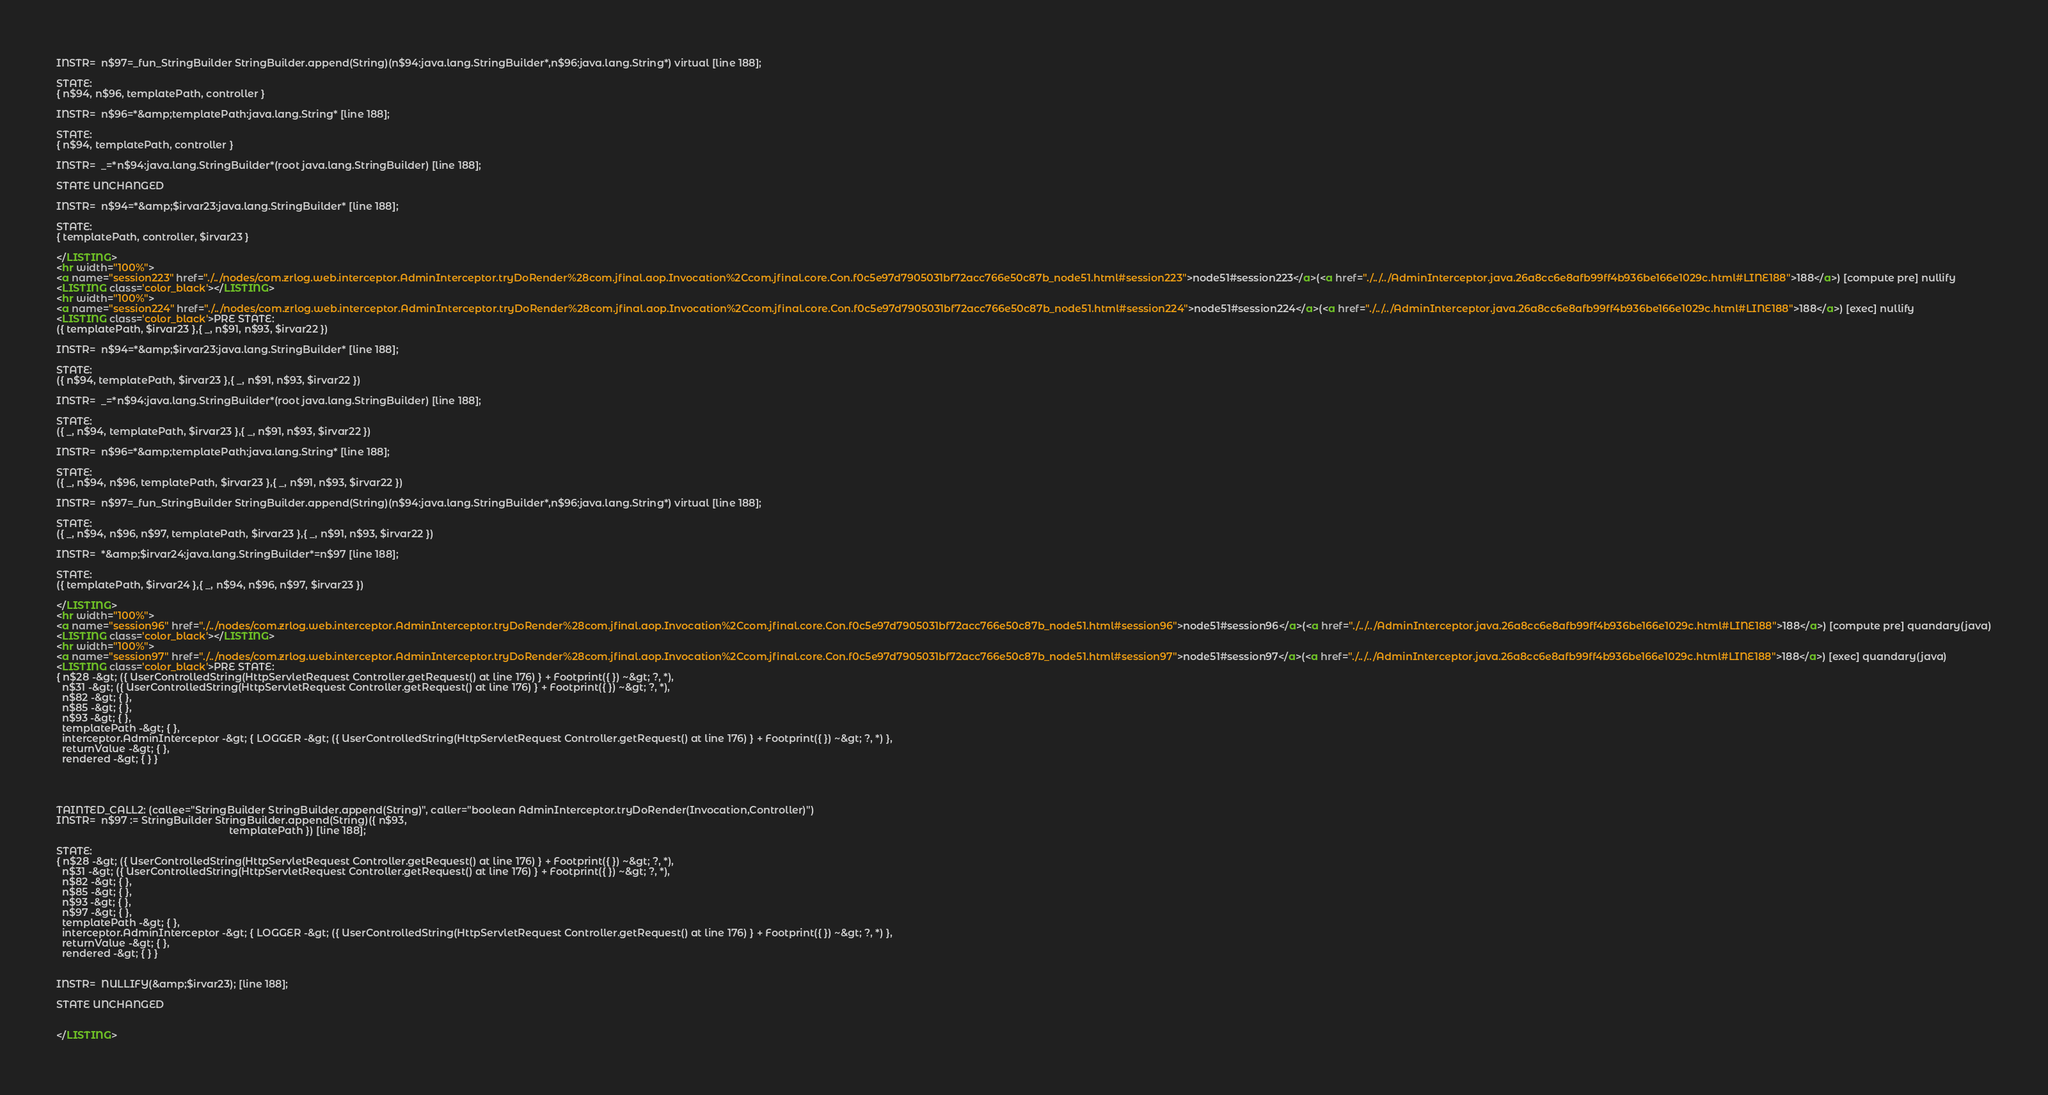Convert code to text. <code><loc_0><loc_0><loc_500><loc_500><_HTML_>INSTR=  n$97=_fun_StringBuilder StringBuilder.append(String)(n$94:java.lang.StringBuilder*,n$96:java.lang.String*) virtual [line 188]; 

STATE:
{ n$94, n$96, templatePath, controller }

INSTR=  n$96=*&amp;templatePath:java.lang.String* [line 188]; 

STATE:
{ n$94, templatePath, controller }

INSTR=  _=*n$94:java.lang.StringBuilder*(root java.lang.StringBuilder) [line 188]; 

STATE UNCHANGED

INSTR=  n$94=*&amp;$irvar23:java.lang.StringBuilder* [line 188]; 

STATE:
{ templatePath, controller, $irvar23 }

</LISTING>
<hr width="100%">
<a name="session223" href="./../nodes/com.zrlog.web.interceptor.AdminInterceptor.tryDoRender%28com.jfinal.aop.Invocation%2Ccom.jfinal.core.Con.f0c5e97d7905031bf72acc766e50c87b_node51.html#session223">node51#session223</a>(<a href="./../../AdminInterceptor.java.26a8cc6e8afb99ff4b936be166e1029c.html#LINE188">188</a>) [compute pre] nullify
<LISTING class='color_black'></LISTING>
<hr width="100%">
<a name="session224" href="./../nodes/com.zrlog.web.interceptor.AdminInterceptor.tryDoRender%28com.jfinal.aop.Invocation%2Ccom.jfinal.core.Con.f0c5e97d7905031bf72acc766e50c87b_node51.html#session224">node51#session224</a>(<a href="./../../AdminInterceptor.java.26a8cc6e8afb99ff4b936be166e1029c.html#LINE188">188</a>) [exec] nullify
<LISTING class='color_black'>PRE STATE:
({ templatePath, $irvar23 },{ _, n$91, n$93, $irvar22 })

INSTR=  n$94=*&amp;$irvar23:java.lang.StringBuilder* [line 188]; 

STATE:
({ n$94, templatePath, $irvar23 },{ _, n$91, n$93, $irvar22 })

INSTR=  _=*n$94:java.lang.StringBuilder*(root java.lang.StringBuilder) [line 188]; 

STATE:
({ _, n$94, templatePath, $irvar23 },{ _, n$91, n$93, $irvar22 })

INSTR=  n$96=*&amp;templatePath:java.lang.String* [line 188]; 

STATE:
({ _, n$94, n$96, templatePath, $irvar23 },{ _, n$91, n$93, $irvar22 })

INSTR=  n$97=_fun_StringBuilder StringBuilder.append(String)(n$94:java.lang.StringBuilder*,n$96:java.lang.String*) virtual [line 188]; 

STATE:
({ _, n$94, n$96, n$97, templatePath, $irvar23 },{ _, n$91, n$93, $irvar22 })

INSTR=  *&amp;$irvar24:java.lang.StringBuilder*=n$97 [line 188]; 

STATE:
({ templatePath, $irvar24 },{ _, n$94, n$96, n$97, $irvar23 })

</LISTING>
<hr width="100%">
<a name="session96" href="./../nodes/com.zrlog.web.interceptor.AdminInterceptor.tryDoRender%28com.jfinal.aop.Invocation%2Ccom.jfinal.core.Con.f0c5e97d7905031bf72acc766e50c87b_node51.html#session96">node51#session96</a>(<a href="./../../AdminInterceptor.java.26a8cc6e8afb99ff4b936be166e1029c.html#LINE188">188</a>) [compute pre] quandary(java)
<LISTING class='color_black'></LISTING>
<hr width="100%">
<a name="session97" href="./../nodes/com.zrlog.web.interceptor.AdminInterceptor.tryDoRender%28com.jfinal.aop.Invocation%2Ccom.jfinal.core.Con.f0c5e97d7905031bf72acc766e50c87b_node51.html#session97">node51#session97</a>(<a href="./../../AdminInterceptor.java.26a8cc6e8afb99ff4b936be166e1029c.html#LINE188">188</a>) [exec] quandary(java)
<LISTING class='color_black'>PRE STATE:
{ n$28 -&gt; ({ UserControlledString(HttpServletRequest Controller.getRequest() at line 176) } + Footprint({ }) ~&gt; ?, *),
  n$31 -&gt; ({ UserControlledString(HttpServletRequest Controller.getRequest() at line 176) } + Footprint({ }) ~&gt; ?, *),
  n$82 -&gt; { },
  n$85 -&gt; { },
  n$93 -&gt; { },
  templatePath -&gt; { },
  interceptor.AdminInterceptor -&gt; { LOGGER -&gt; ({ UserControlledString(HttpServletRequest Controller.getRequest() at line 176) } + Footprint({ }) ~&gt; ?, *) },
  returnValue -&gt; { },
  rendered -&gt; { } }




TAINTED_CALL2: (callee="StringBuilder StringBuilder.append(String)", caller="boolean AdminInterceptor.tryDoRender(Invocation,Controller)")
INSTR=  n$97 := StringBuilder StringBuilder.append(String)({ n$93,
                                                             templatePath }) [line 188]; 

STATE:
{ n$28 -&gt; ({ UserControlledString(HttpServletRequest Controller.getRequest() at line 176) } + Footprint({ }) ~&gt; ?, *),
  n$31 -&gt; ({ UserControlledString(HttpServletRequest Controller.getRequest() at line 176) } + Footprint({ }) ~&gt; ?, *),
  n$82 -&gt; { },
  n$85 -&gt; { },
  n$93 -&gt; { },
  n$97 -&gt; { },
  templatePath -&gt; { },
  interceptor.AdminInterceptor -&gt; { LOGGER -&gt; ({ UserControlledString(HttpServletRequest Controller.getRequest() at line 176) } + Footprint({ }) ~&gt; ?, *) },
  returnValue -&gt; { },
  rendered -&gt; { } }


INSTR=  NULLIFY(&amp;$irvar23); [line 188]; 

STATE UNCHANGED


</LISTING></code> 